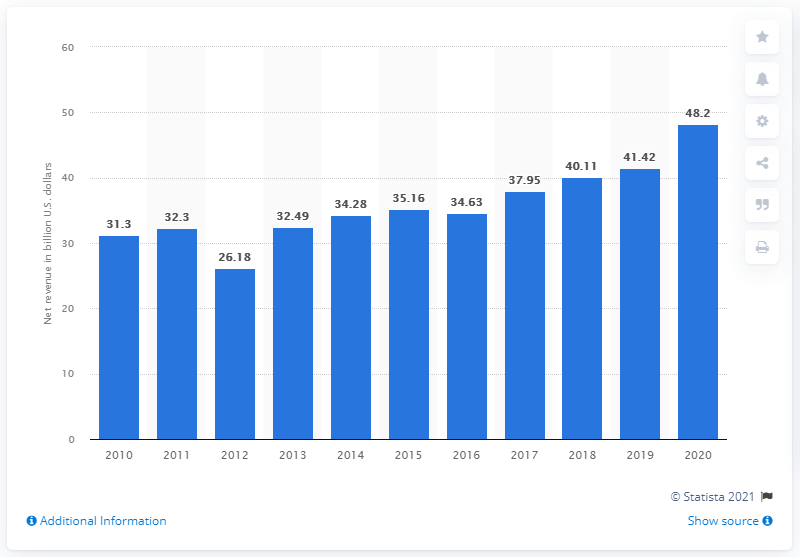Draw attention to some important aspects in this diagram. Morgan Stanley's net revenues in 2020 were approximately $48.2 billion. 